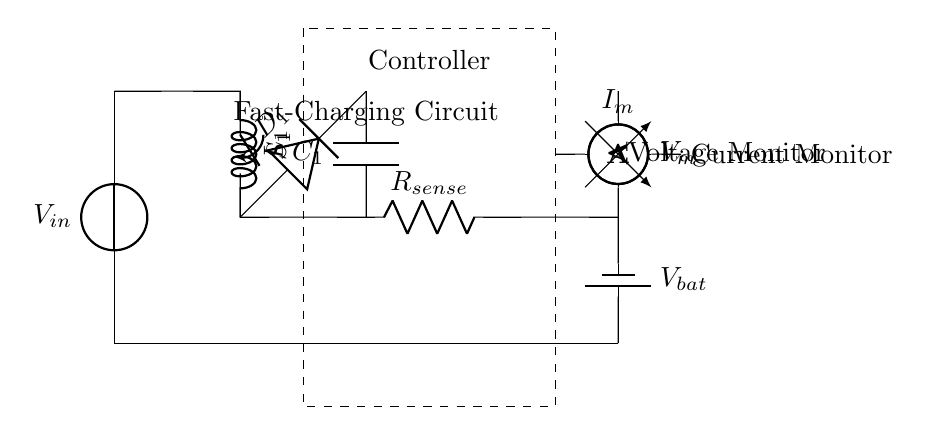What type of converter is used in this circuit? The circuit uses a buck converter, as indicated by the labeled component that steps down the voltage from the input source to the output level.
Answer: Buck converter What is the role of the switch labeled S1? The switch S1 controls the operation of the buck converter by opening or closing the connection, thus modulating the flow of current through the inductor and the rest of the circuit.
Answer: Controls current What component is used for voltage measurement? The voltmeter is the component used for voltage measurement, as indicated by its labeling and placement across the battery and current sensing resistor.
Answer: Voltmeter Which component measures current in this circuit? The ammeter measures current, as indicated by its label and position in series with the current sensing resistor, allowing for accurate current measurement in this circuit design.
Answer: Ammeter What does R_sense represent in this circuit? R_sense is the sense resistor used to measure the current flowing through the circuit by producing a small voltage drop proportional to the current, which can be monitored to control charging.
Answer: Sense resistor What is the purpose of the capacitor C1 in this circuit? The capacitor C1 serves to smooth out ripples in the output voltage from the buck converter, providing a stable voltage supply to the connected battery while charging.
Answer: Smoothing How does the controller affect the charging process? The controller regulates the operation of the buck converter by processing the data from the voltage and current measurements, adjusting the switch S1 accordingly to maintain optimal charging conditions for the battery.
Answer: Regulates charging 